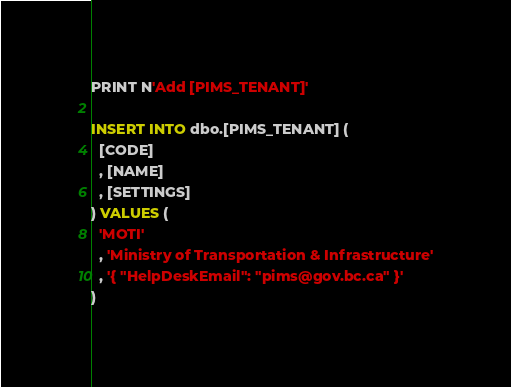Convert code to text. <code><loc_0><loc_0><loc_500><loc_500><_SQL_>PRINT N'Add [PIMS_TENANT]'

INSERT INTO dbo.[PIMS_TENANT] (
  [CODE]
  , [NAME]
  , [SETTINGS]
) VALUES (
  'MOTI'
  , 'Ministry of Transportation & Infrastructure'
  , '{ "HelpDeskEmail": "pims@gov.bc.ca" }'
)</code> 